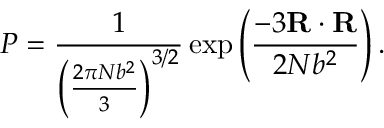Convert formula to latex. <formula><loc_0><loc_0><loc_500><loc_500>P = { \frac { 1 } { \left ( { \frac { 2 \pi N b ^ { 2 } } { 3 } } \right ) ^ { 3 / 2 } } } \exp \left ( { \frac { - 3 R \cdot R } { 2 N b ^ { 2 } } } \right ) .</formula> 